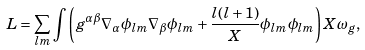<formula> <loc_0><loc_0><loc_500><loc_500>L = \sum _ { l m } \int \left ( g ^ { \alpha \beta } \nabla _ { \alpha } \phi _ { l m } \nabla _ { \beta } \phi _ { l m } + \frac { l ( l + 1 ) } { X } \phi _ { l m } \phi _ { l m } \right ) X \omega _ { g } ,</formula> 